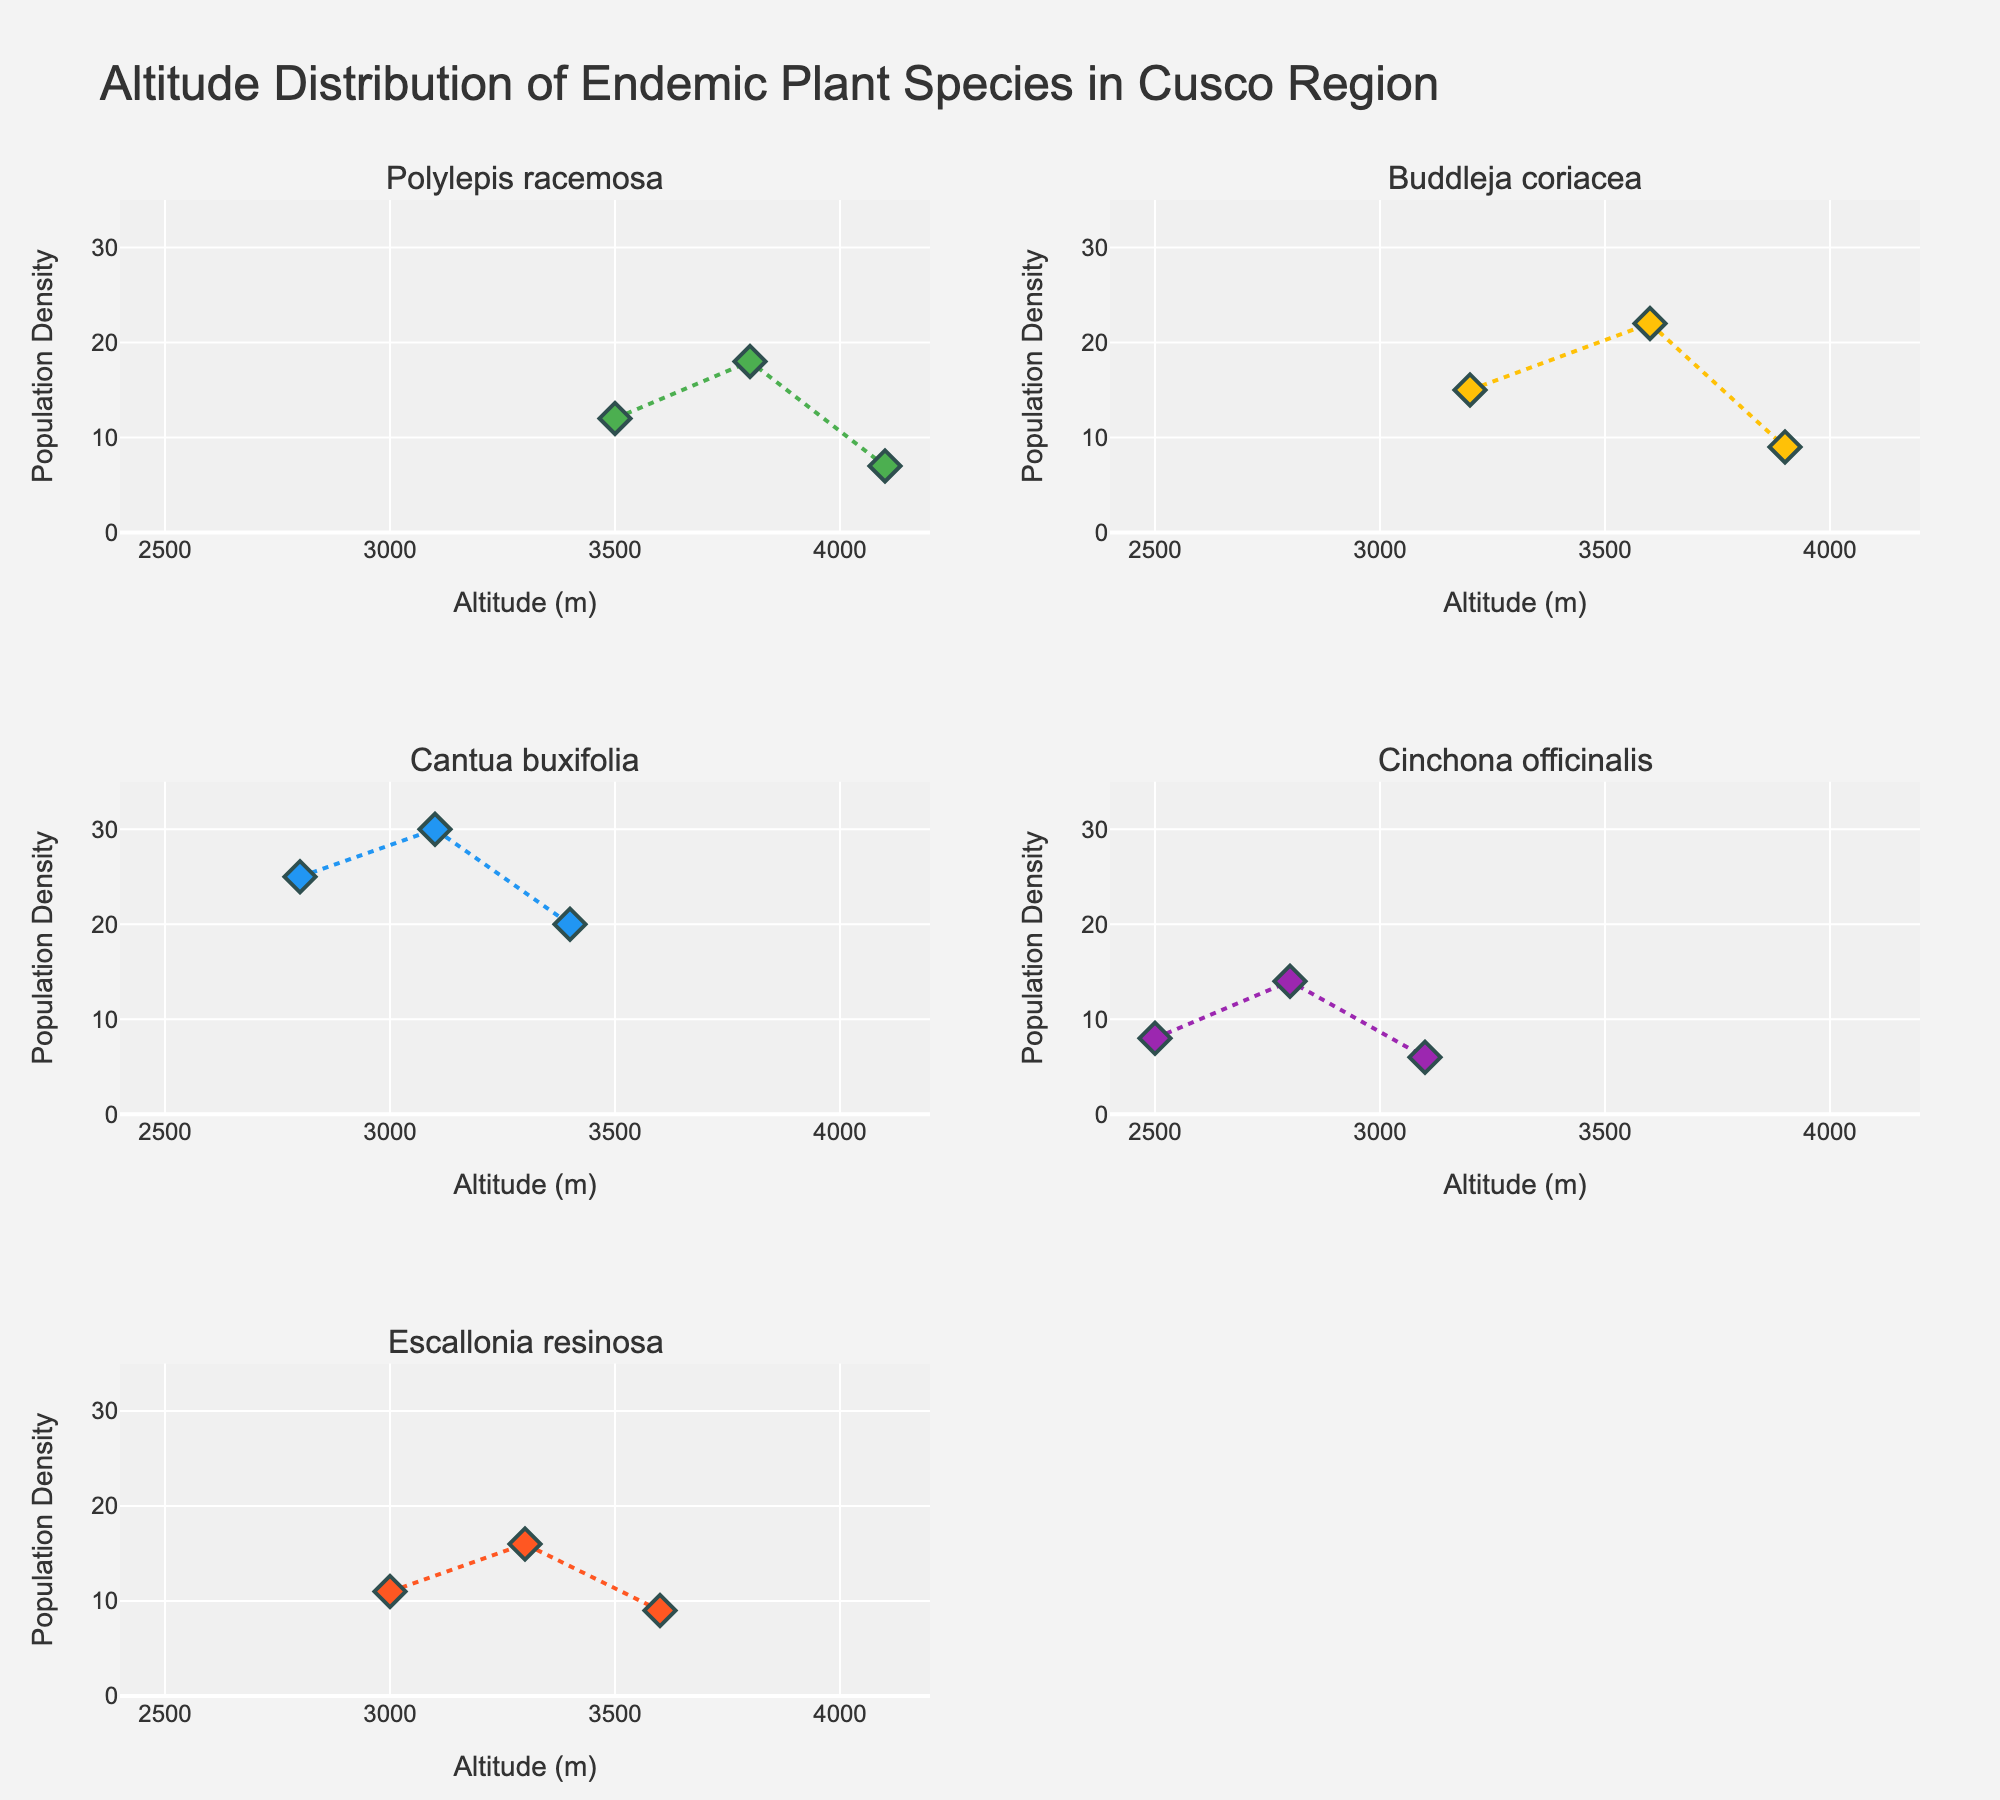How many times does the species Polylepis racemosa appear in the data? Look at the subplot for Polylepis racemosa and count the number of markers (each representing a data point).
Answer: 3 Which plant species has the highest recorded population density? Identify the highest y-value (population density) across all the subplots, which is for Cantua buxifolia with a population density of 30.
Answer: Cantua buxifolia What is the average altitude for Buddleja coriacea? Sum the altitude values for Buddleja coriacea (3200 + 3600 + 3900 = 10700) and divide by the number of data points (3).
Answer: 3567 meters Is there any species that appears in both the first and second subplots? If so, which one? Check the titles of the subplots in the first row (columns 1 and 2) and compare the species.
Answer: No, there isn't Which species shows a decrease in population density as altitude increases? Look at the trend lines in each subplot, Escallonia resinosa shows a decrease in population density as altitude increases.
Answer: Escallonia resinosa What is the population density range for Cinchona officinalis? Identify the minimum and maximum population densities in the Cinchona officinalis subplot.
Answer: 6 to 14 If the population density for Buddleja coriacea is predicted to decrease by 5 for every 300 meters increase in altitude, what would be the population density at 4200 meters? The current highest altitude for Buddleja coriacea is 3900 meters with a population density of 9. Extrapolating to 4200 meters (an increase of 300 meters), decrease the density by 5 (9 - 5).
Answer: 4 